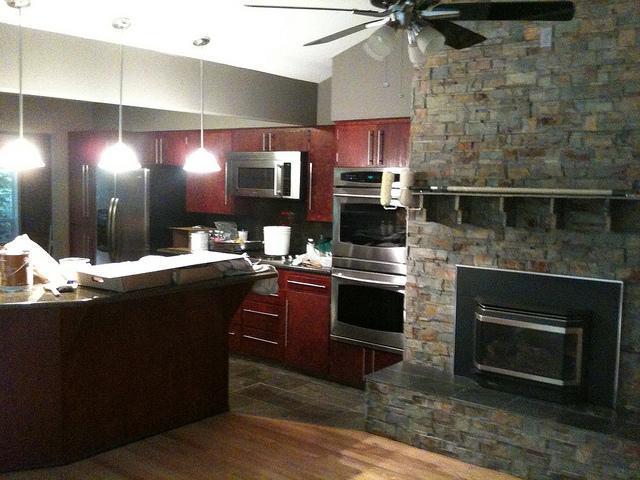How many refrigerators are in the photo?
Give a very brief answer. 2. How many horses are shown?
Give a very brief answer. 0. 